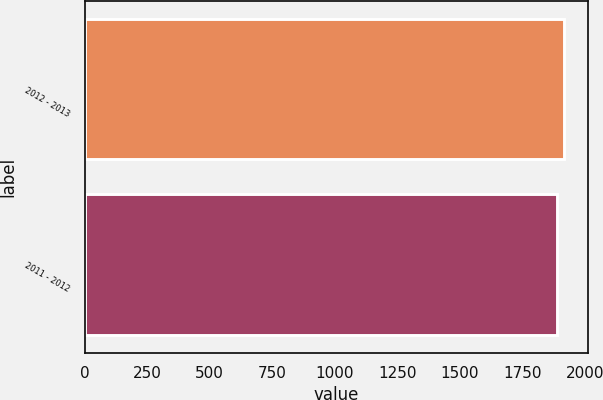Convert chart to OTSL. <chart><loc_0><loc_0><loc_500><loc_500><bar_chart><fcel>2012 - 2013<fcel>2011 - 2012<nl><fcel>1917.9<fcel>1887.2<nl></chart> 